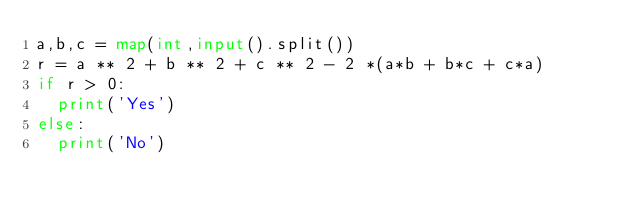<code> <loc_0><loc_0><loc_500><loc_500><_Python_>a,b,c = map(int,input().split())
r = a ** 2 + b ** 2 + c ** 2 - 2 *(a*b + b*c + c*a)
if r > 0:
	print('Yes')
else:
	print('No')
</code> 